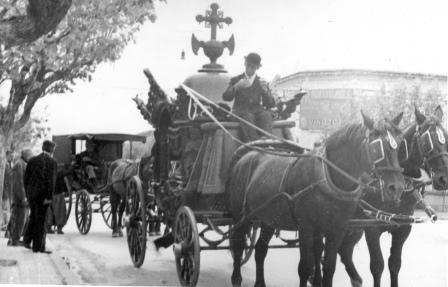What is pulling the man?
Answer briefly. Horses. How many carriages?
Concise answer only. 2. Can you ride in this carriage?
Be succinct. Yes. How many horses are pulling the front carriage?
Keep it brief. 2. 